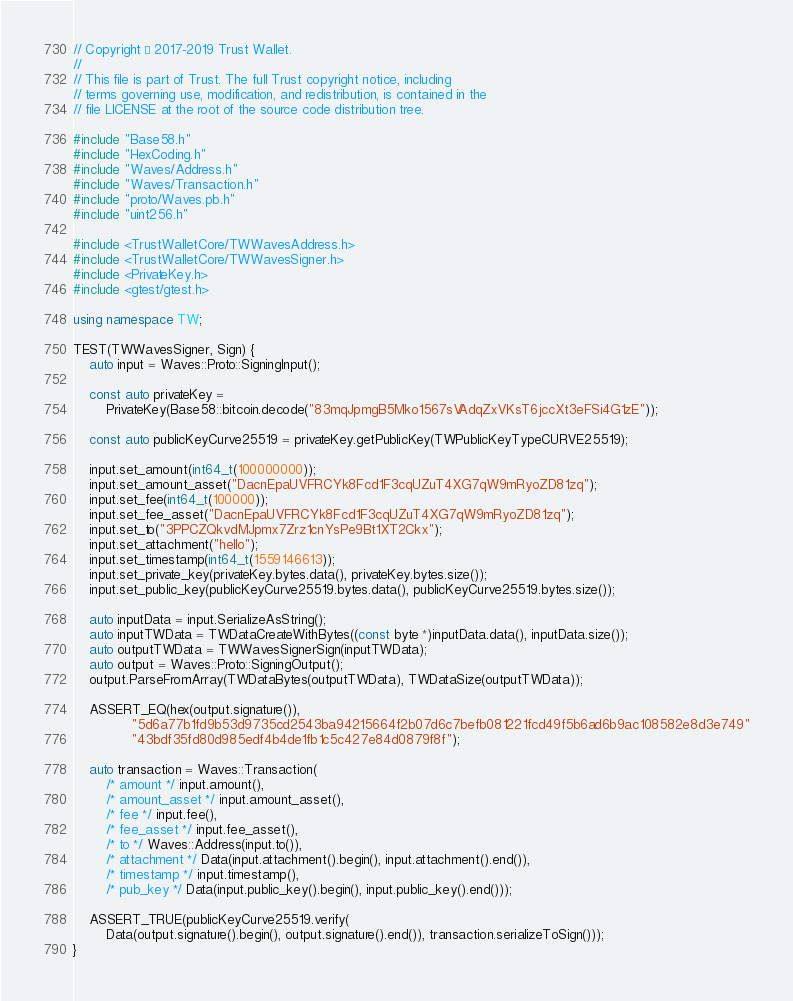Convert code to text. <code><loc_0><loc_0><loc_500><loc_500><_C++_>// Copyright © 2017-2019 Trust Wallet.
//
// This file is part of Trust. The full Trust copyright notice, including
// terms governing use, modification, and redistribution, is contained in the
// file LICENSE at the root of the source code distribution tree.

#include "Base58.h"
#include "HexCoding.h"
#include "Waves/Address.h"
#include "Waves/Transaction.h"
#include "proto/Waves.pb.h"
#include "uint256.h"

#include <TrustWalletCore/TWWavesAddress.h>
#include <TrustWalletCore/TWWavesSigner.h>
#include <PrivateKey.h>
#include <gtest/gtest.h>

using namespace TW;

TEST(TWWavesSigner, Sign) {
    auto input = Waves::Proto::SigningInput();

    const auto privateKey =
        PrivateKey(Base58::bitcoin.decode("83mqJpmgB5Mko1567sVAdqZxVKsT6jccXt3eFSi4G1zE"));

    const auto publicKeyCurve25519 = privateKey.getPublicKey(TWPublicKeyTypeCURVE25519);

    input.set_amount(int64_t(100000000));
    input.set_amount_asset("DacnEpaUVFRCYk8Fcd1F3cqUZuT4XG7qW9mRyoZD81zq");
    input.set_fee(int64_t(100000));
    input.set_fee_asset("DacnEpaUVFRCYk8Fcd1F3cqUZuT4XG7qW9mRyoZD81zq");
    input.set_to("3PPCZQkvdMJpmx7Zrz1cnYsPe9Bt1XT2Ckx");
    input.set_attachment("hello");
    input.set_timestamp(int64_t(1559146613));
    input.set_private_key(privateKey.bytes.data(), privateKey.bytes.size());
    input.set_public_key(publicKeyCurve25519.bytes.data(), publicKeyCurve25519.bytes.size());

    auto inputData = input.SerializeAsString();
    auto inputTWData = TWDataCreateWithBytes((const byte *)inputData.data(), inputData.size());
    auto outputTWData = TWWavesSignerSign(inputTWData);
    auto output = Waves::Proto::SigningOutput();
    output.ParseFromArray(TWDataBytes(outputTWData), TWDataSize(outputTWData));

    ASSERT_EQ(hex(output.signature()),
              "5d6a77b1fd9b53d9735cd2543ba94215664f2b07d6c7befb081221fcd49f5b6ad6b9ac108582e8d3e749"
              "43bdf35fd80d985edf4b4de1fb1c5c427e84d0879f8f");

    auto transaction = Waves::Transaction(
        /* amount */ input.amount(),
        /* amount_asset */ input.amount_asset(),
        /* fee */ input.fee(),
        /* fee_asset */ input.fee_asset(),
        /* to */ Waves::Address(input.to()),
        /* attachment */ Data(input.attachment().begin(), input.attachment().end()),
        /* timestamp */ input.timestamp(),
        /* pub_key */ Data(input.public_key().begin(), input.public_key().end()));

    ASSERT_TRUE(publicKeyCurve25519.verify(
        Data(output.signature().begin(), output.signature().end()), transaction.serializeToSign()));
}
</code> 